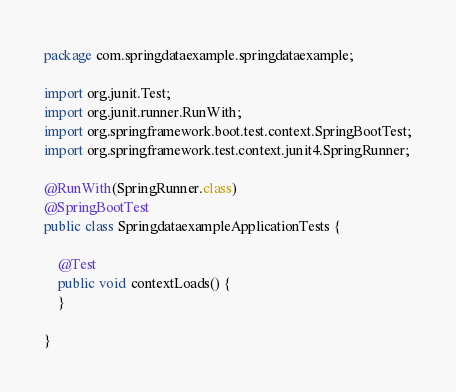<code> <loc_0><loc_0><loc_500><loc_500><_Java_>package com.springdataexample.springdataexample;

import org.junit.Test;
import org.junit.runner.RunWith;
import org.springframework.boot.test.context.SpringBootTest;
import org.springframework.test.context.junit4.SpringRunner;

@RunWith(SpringRunner.class)
@SpringBootTest
public class SpringdataexampleApplicationTests {

	@Test
	public void contextLoads() {
	}

}

</code> 